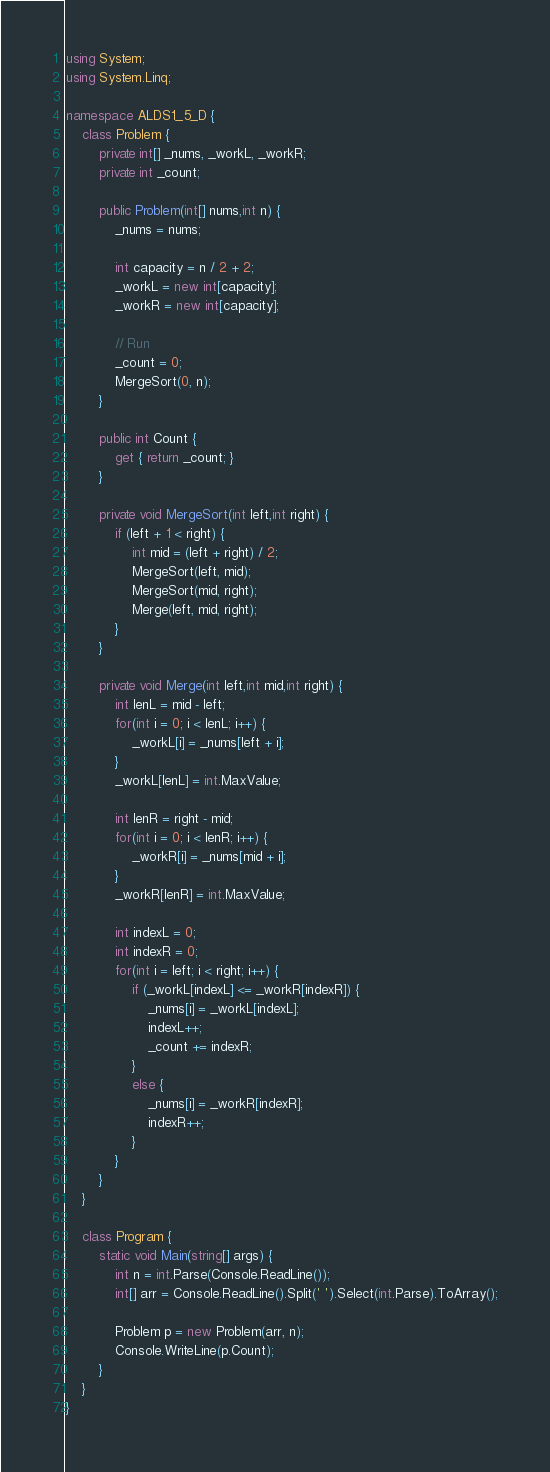Convert code to text. <code><loc_0><loc_0><loc_500><loc_500><_C#_>using System;
using System.Linq;

namespace ALDS1_5_D {
    class Problem {
        private int[] _nums, _workL, _workR;
        private int _count;

        public Problem(int[] nums,int n) {
            _nums = nums;

            int capacity = n / 2 + 2;
            _workL = new int[capacity];
            _workR = new int[capacity];

            // Run
            _count = 0;
            MergeSort(0, n);
        }

        public int Count {
            get { return _count; }
        }
        
        private void MergeSort(int left,int right) {
            if (left + 1 < right) {
                int mid = (left + right) / 2;
                MergeSort(left, mid);
                MergeSort(mid, right);
                Merge(left, mid, right);
            }
        }

        private void Merge(int left,int mid,int right) {
            int lenL = mid - left;
            for(int i = 0; i < lenL; i++) {
                _workL[i] = _nums[left + i];
            }
            _workL[lenL] = int.MaxValue;

            int lenR = right - mid;
            for(int i = 0; i < lenR; i++) {
                _workR[i] = _nums[mid + i];
            }
            _workR[lenR] = int.MaxValue;

            int indexL = 0;
            int indexR = 0;
            for(int i = left; i < right; i++) {
                if (_workL[indexL] <= _workR[indexR]) {
                    _nums[i] = _workL[indexL];
                    indexL++;
                    _count += indexR;
                }
                else {
                    _nums[i] = _workR[indexR];
                    indexR++;
                }
            }
        }
    }

    class Program {
        static void Main(string[] args) {
            int n = int.Parse(Console.ReadLine());
            int[] arr = Console.ReadLine().Split(' ').Select(int.Parse).ToArray();

            Problem p = new Problem(arr, n);
            Console.WriteLine(p.Count);
        }
    }
}</code> 